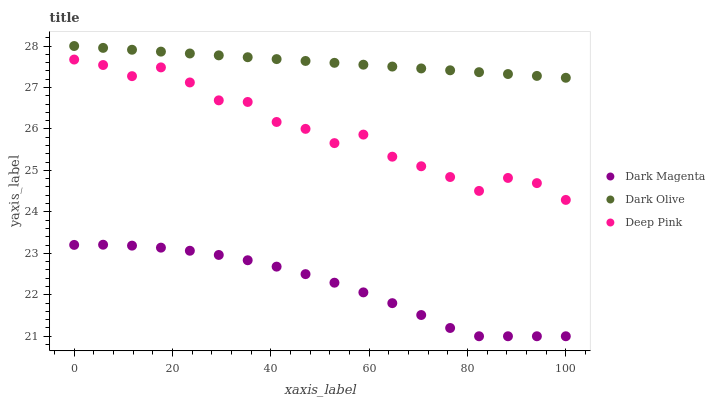Does Dark Magenta have the minimum area under the curve?
Answer yes or no. Yes. Does Dark Olive have the maximum area under the curve?
Answer yes or no. Yes. Does Deep Pink have the minimum area under the curve?
Answer yes or no. No. Does Deep Pink have the maximum area under the curve?
Answer yes or no. No. Is Dark Olive the smoothest?
Answer yes or no. Yes. Is Deep Pink the roughest?
Answer yes or no. Yes. Is Dark Magenta the smoothest?
Answer yes or no. No. Is Dark Magenta the roughest?
Answer yes or no. No. Does Dark Magenta have the lowest value?
Answer yes or no. Yes. Does Deep Pink have the lowest value?
Answer yes or no. No. Does Dark Olive have the highest value?
Answer yes or no. Yes. Does Deep Pink have the highest value?
Answer yes or no. No. Is Dark Magenta less than Dark Olive?
Answer yes or no. Yes. Is Dark Olive greater than Dark Magenta?
Answer yes or no. Yes. Does Dark Magenta intersect Dark Olive?
Answer yes or no. No. 